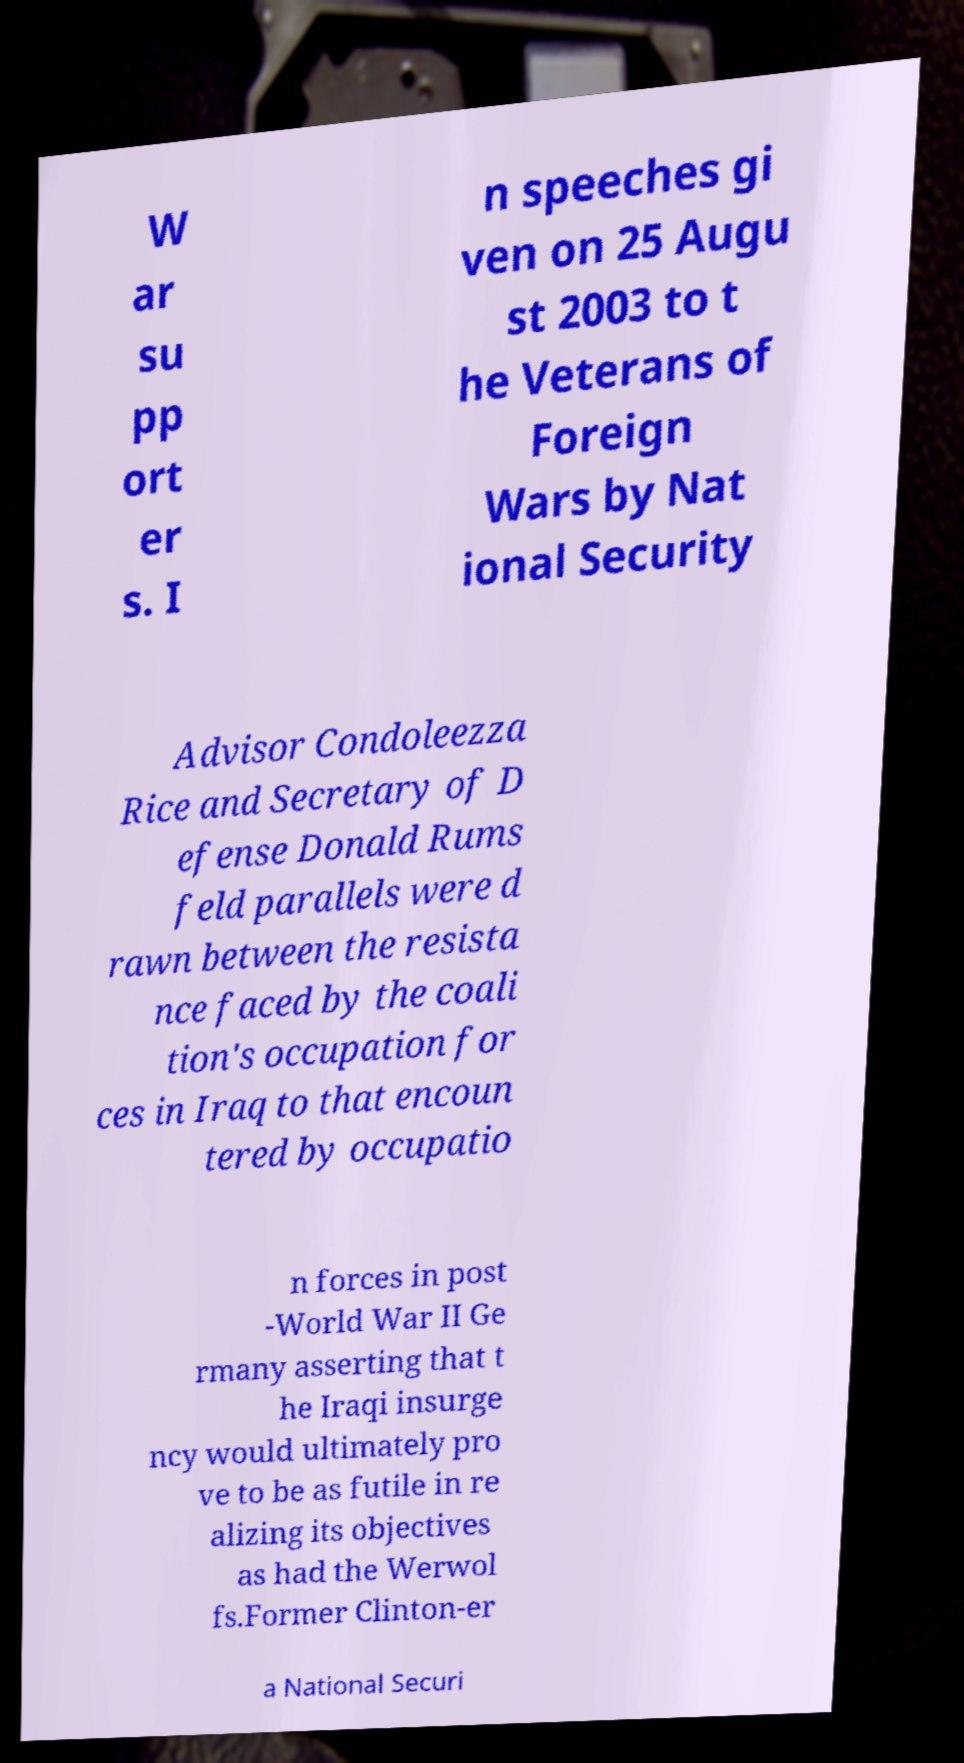Could you extract and type out the text from this image? W ar su pp ort er s. I n speeches gi ven on 25 Augu st 2003 to t he Veterans of Foreign Wars by Nat ional Security Advisor Condoleezza Rice and Secretary of D efense Donald Rums feld parallels were d rawn between the resista nce faced by the coali tion's occupation for ces in Iraq to that encoun tered by occupatio n forces in post -World War II Ge rmany asserting that t he Iraqi insurge ncy would ultimately pro ve to be as futile in re alizing its objectives as had the Werwol fs.Former Clinton-er a National Securi 